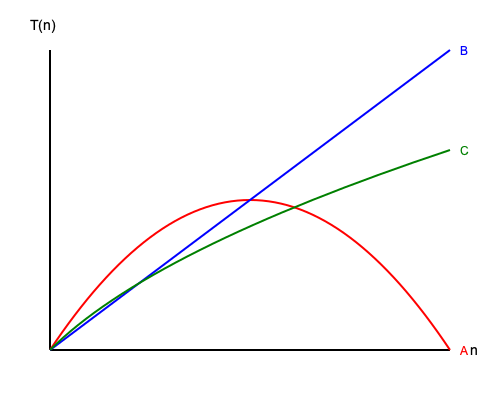As an experienced software engineer maintaining a data manipulation library, you're analyzing the time complexity of different sorting algorithms. The graph shows the running time T(n) versus input size n for three sorting algorithms (A, B, and C). Which algorithm is most likely to be Quicksort with an average-case time complexity, and what is its Big O notation? To determine which algorithm is most likely to be Quicksort and its Big O notation, let's analyze the graph step-by-step:

1. Identify the curves:
   - Curve A (red): Quadratic growth
   - Curve B (blue): Linear growth
   - Curve C (green): Logarithmic or linearithmic growth

2. Recall the time complexities of common sorting algorithms:
   - Bubble Sort, Selection Sort, Insertion Sort: $O(n^2)$
   - Merge Sort, Heapsort: $O(n \log n)$
   - Quicksort (average case): $O(n \log n)$
   - Quicksort (worst case): $O(n^2)$

3. Analyze each curve:
   - Curve A: Quadratic growth, typical of $O(n^2)$ algorithms
   - Curve B: Linear growth, not typical for comparison-based sorting algorithms
   - Curve C: Shows a growth rate between linear and quadratic, consistent with $O(n \log n)$

4. Consider Quicksort's characteristics:
   - Average-case time complexity: $O(n \log n)$
   - Performs well in practice due to low constant factors and good cache performance

5. Match the algorithm to the curve:
   Curve C (green) most closely resembles the expected performance of Quicksort in its average case. It shows a growth rate consistent with $O(n \log n)$, which is faster than quadratic but slower than linear.

Therefore, algorithm C is most likely to be Quicksort with an average-case time complexity.
Answer: Algorithm C, $O(n \log n)$ 